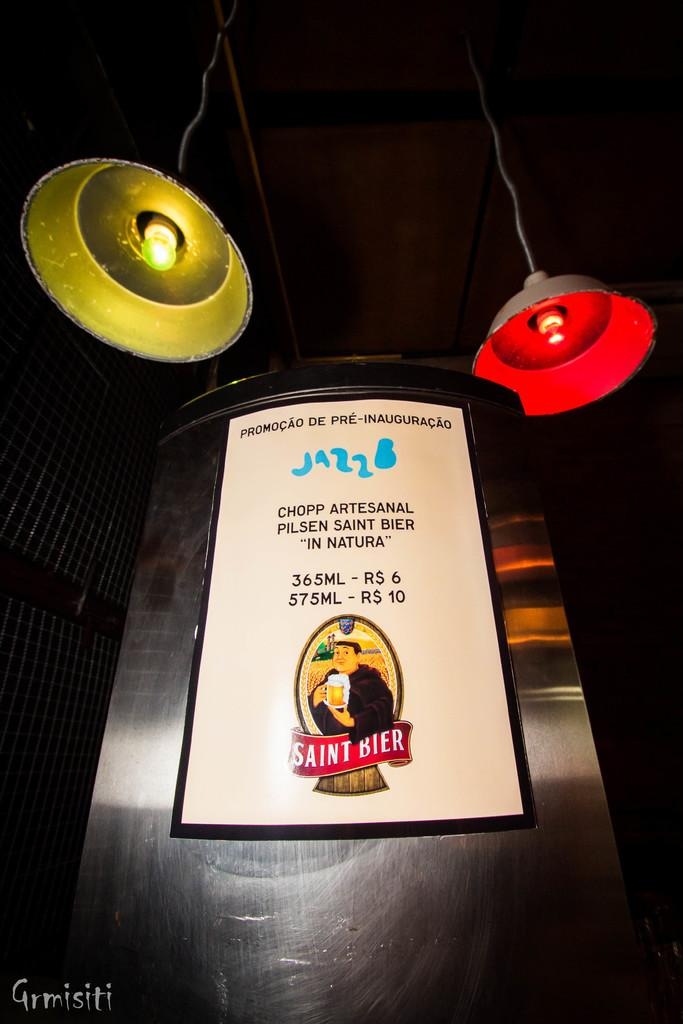<image>
Share a concise interpretation of the image provided. A large metal case has a Saint Bier sign on it. 